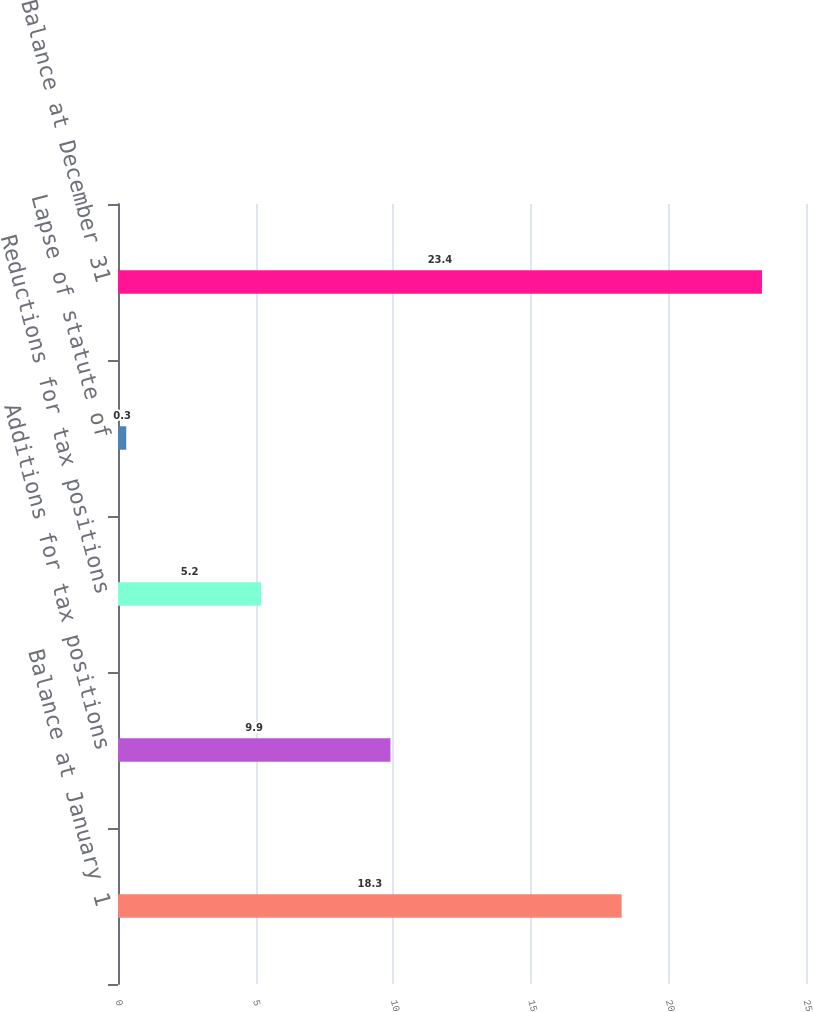Convert chart. <chart><loc_0><loc_0><loc_500><loc_500><bar_chart><fcel>Balance at January 1<fcel>Additions for tax positions<fcel>Reductions for tax positions<fcel>Lapse of statute of<fcel>Balance at December 31<nl><fcel>18.3<fcel>9.9<fcel>5.2<fcel>0.3<fcel>23.4<nl></chart> 